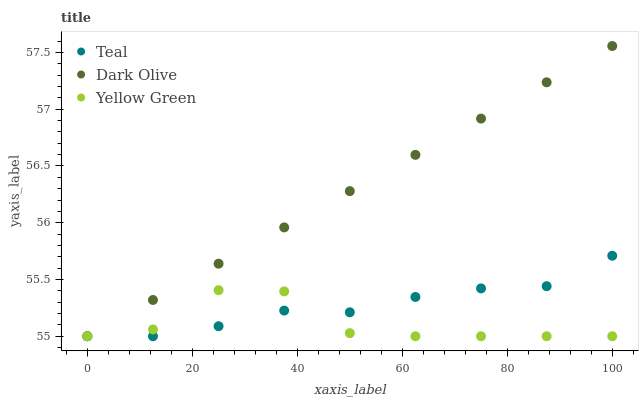Does Yellow Green have the minimum area under the curve?
Answer yes or no. Yes. Does Dark Olive have the maximum area under the curve?
Answer yes or no. Yes. Does Teal have the minimum area under the curve?
Answer yes or no. No. Does Teal have the maximum area under the curve?
Answer yes or no. No. Is Dark Olive the smoothest?
Answer yes or no. Yes. Is Yellow Green the roughest?
Answer yes or no. Yes. Is Teal the smoothest?
Answer yes or no. No. Is Teal the roughest?
Answer yes or no. No. Does Dark Olive have the lowest value?
Answer yes or no. Yes. Does Dark Olive have the highest value?
Answer yes or no. Yes. Does Teal have the highest value?
Answer yes or no. No. Does Dark Olive intersect Yellow Green?
Answer yes or no. Yes. Is Dark Olive less than Yellow Green?
Answer yes or no. No. Is Dark Olive greater than Yellow Green?
Answer yes or no. No. 